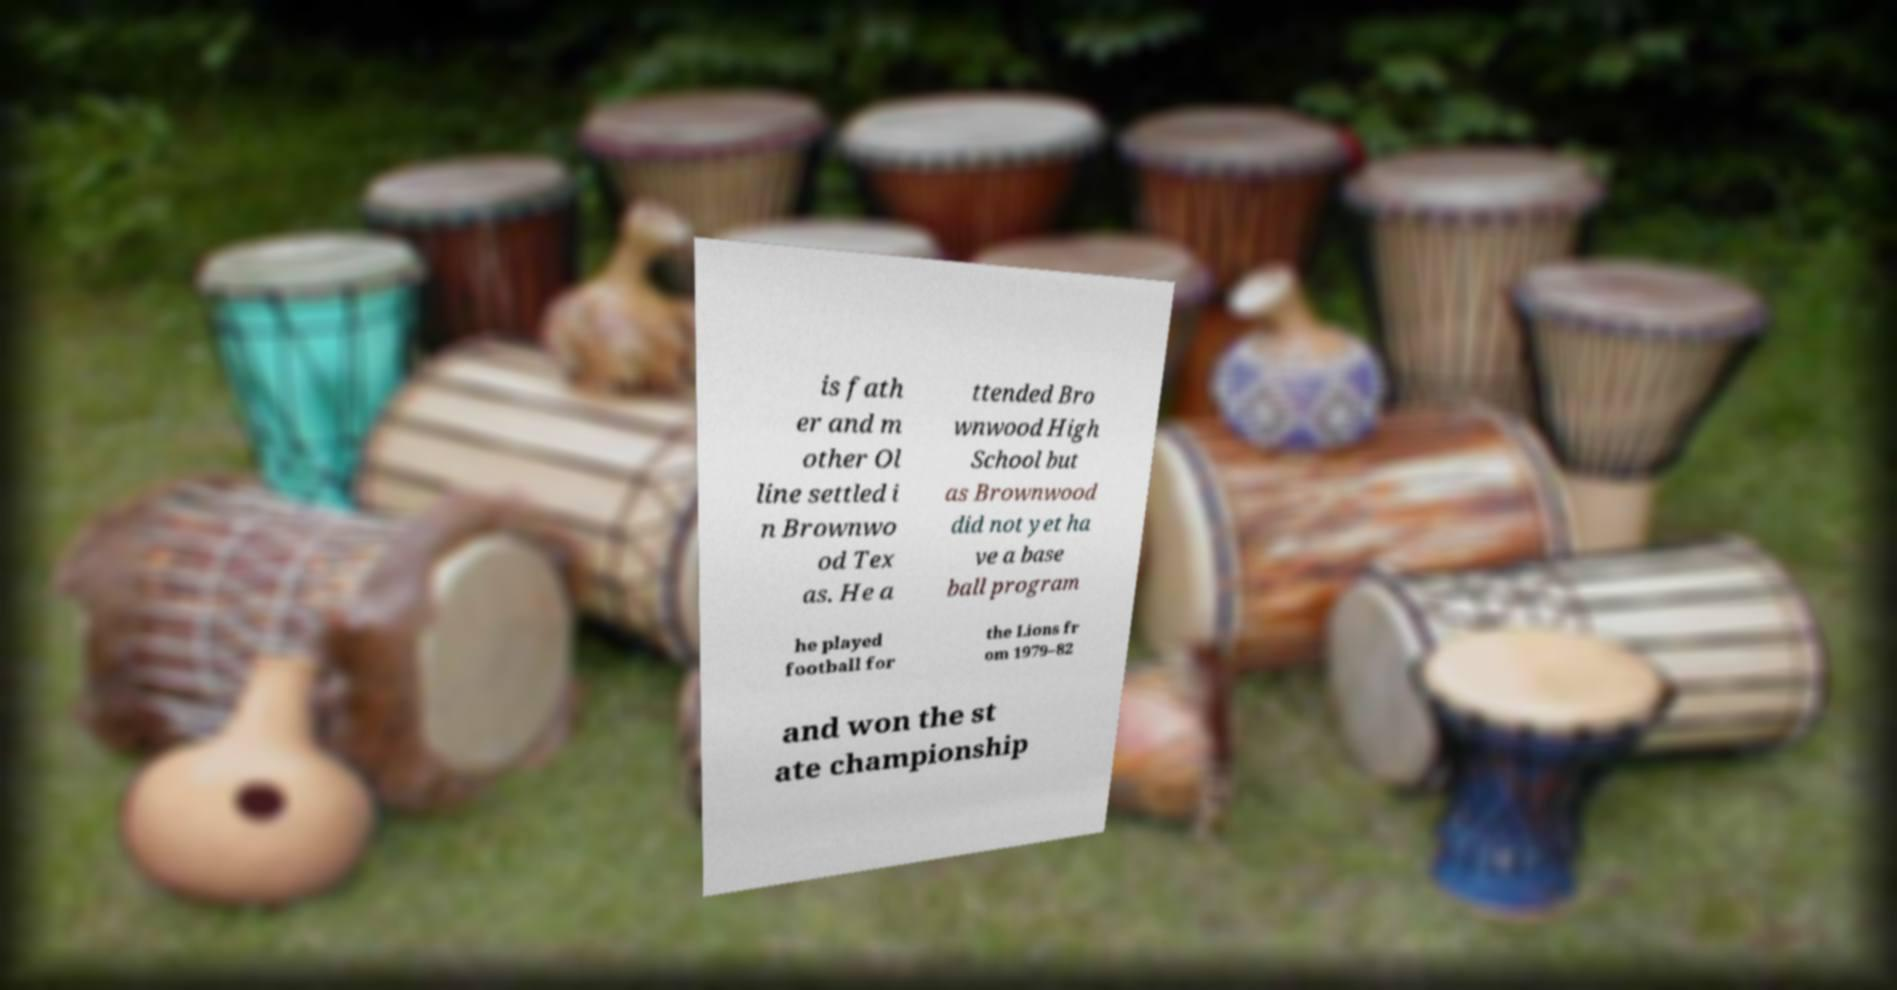Can you read and provide the text displayed in the image?This photo seems to have some interesting text. Can you extract and type it out for me? is fath er and m other Ol line settled i n Brownwo od Tex as. He a ttended Bro wnwood High School but as Brownwood did not yet ha ve a base ball program he played football for the Lions fr om 1979–82 and won the st ate championship 